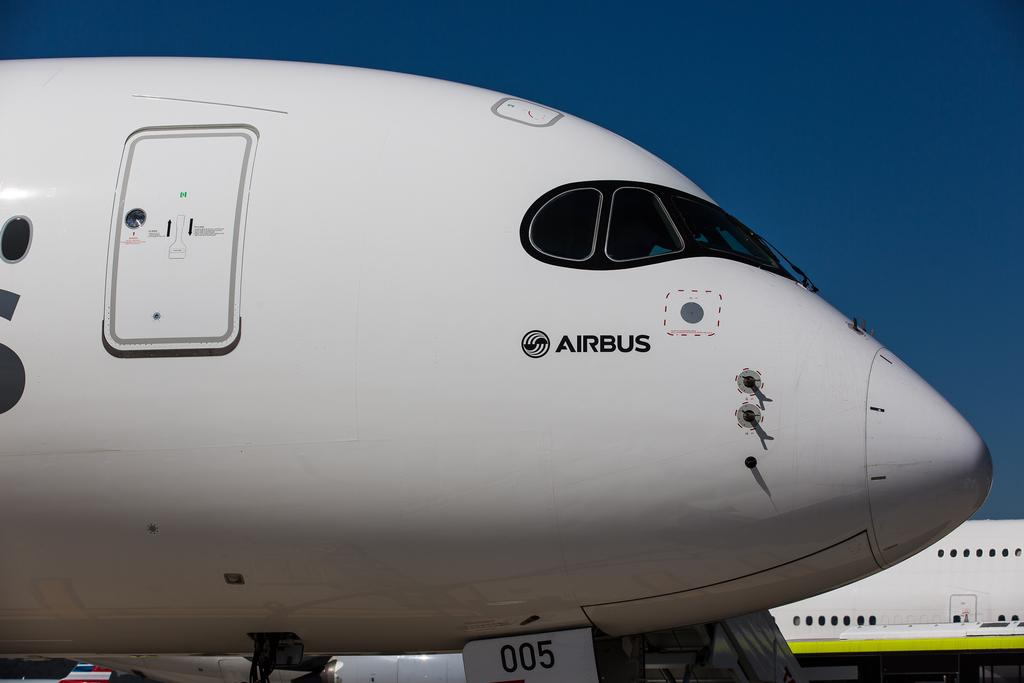<image>
Present a compact description of the photo's key features. The type of plane show here is an Airbus 